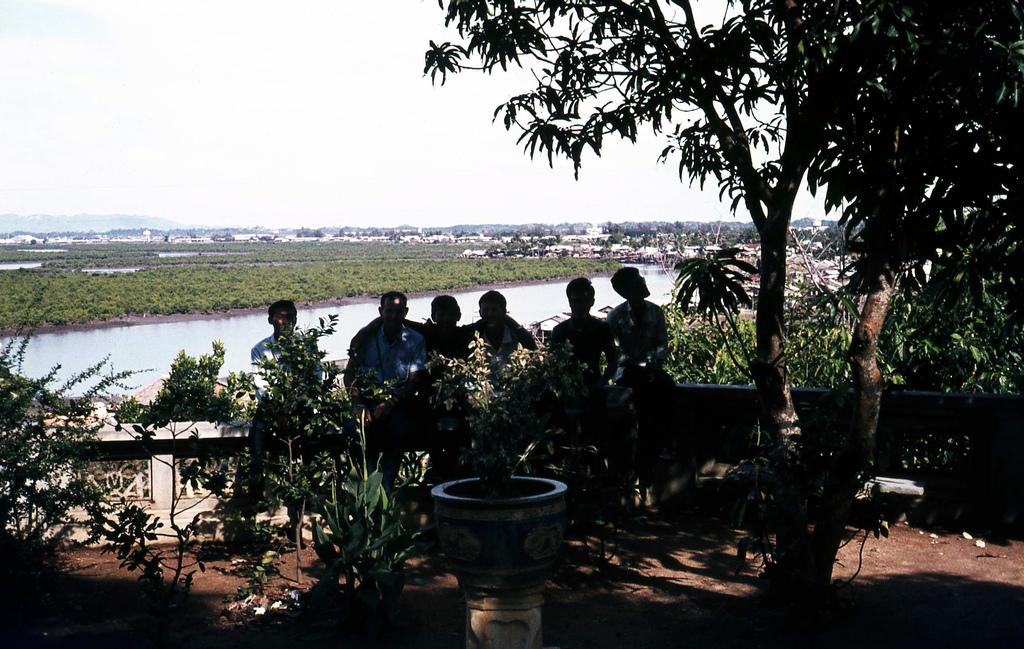What is the main subject in the center of the image? There are men in the center of the image. What can be seen on the sides of the image? There are trees on both the right and left sides of the image. What is located in the center of the image besides the men? There is water in the center of the image. What type of ornament is hanging from the trees in the image? There are no ornaments hanging from the trees in the image; only trees and men are visible. 